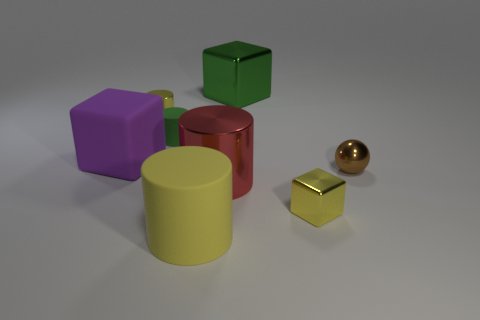Is the material of the big green cube the same as the large yellow cylinder?
Your answer should be very brief. No. What number of objects are either big rubber objects in front of the tiny metal ball or metallic things that are in front of the big metal block?
Offer a very short reply. 5. Is there a green block of the same size as the green matte object?
Provide a short and direct response. No. There is a rubber object that is the same shape as the big green metallic thing; what is its color?
Give a very brief answer. Purple. There is a shiny cylinder that is in front of the big purple thing; are there any small objects that are on the right side of it?
Your answer should be very brief. Yes. There is a tiny metallic thing that is on the left side of the large rubber cylinder; is its shape the same as the large purple thing?
Make the answer very short. No. What shape is the purple matte object?
Your response must be concise. Cube. What number of big yellow things are made of the same material as the red cylinder?
Your answer should be very brief. 0. Does the tiny metallic cylinder have the same color as the metallic block that is in front of the green metallic cube?
Make the answer very short. Yes. What number of small gray rubber things are there?
Your answer should be very brief. 0. 